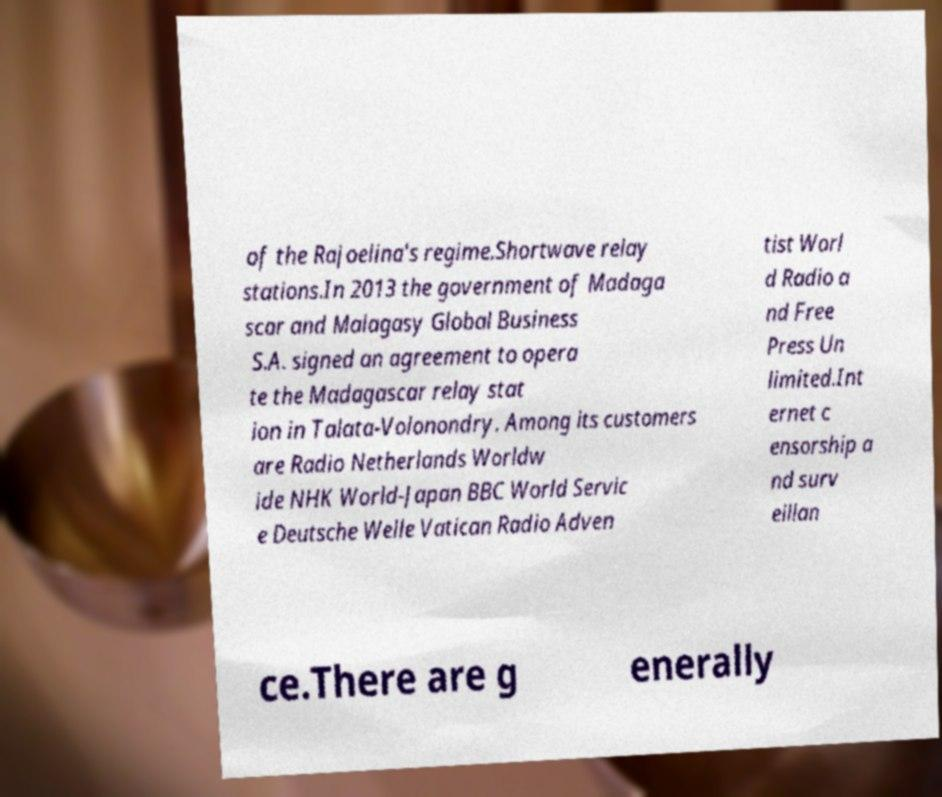Can you accurately transcribe the text from the provided image for me? of the Rajoelina's regime.Shortwave relay stations.In 2013 the government of Madaga scar and Malagasy Global Business S.A. signed an agreement to opera te the Madagascar relay stat ion in Talata-Volonondry. Among its customers are Radio Netherlands Worldw ide NHK World-Japan BBC World Servic e Deutsche Welle Vatican Radio Adven tist Worl d Radio a nd Free Press Un limited.Int ernet c ensorship a nd surv eillan ce.There are g enerally 